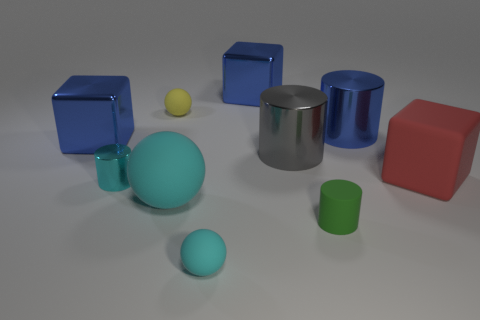How many objects are in this image and can you describe them? There are a total of seven objects in the image, including two turquoise matte cylinders, one large and one small; a shiny metallic cylinder; two shiny blue cubes; a small matte yellow sphere; and a matte red cube. The objects vary in size and finish, creating a diverse array of shapes and textures. 